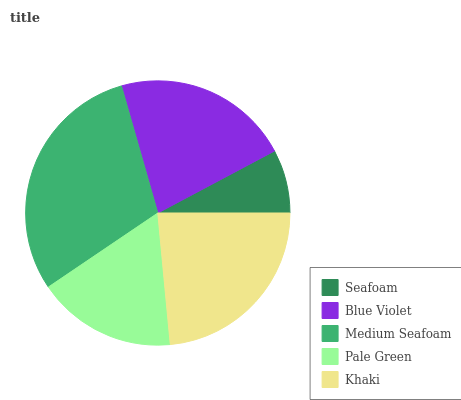Is Seafoam the minimum?
Answer yes or no. Yes. Is Medium Seafoam the maximum?
Answer yes or no. Yes. Is Blue Violet the minimum?
Answer yes or no. No. Is Blue Violet the maximum?
Answer yes or no. No. Is Blue Violet greater than Seafoam?
Answer yes or no. Yes. Is Seafoam less than Blue Violet?
Answer yes or no. Yes. Is Seafoam greater than Blue Violet?
Answer yes or no. No. Is Blue Violet less than Seafoam?
Answer yes or no. No. Is Blue Violet the high median?
Answer yes or no. Yes. Is Blue Violet the low median?
Answer yes or no. Yes. Is Khaki the high median?
Answer yes or no. No. Is Medium Seafoam the low median?
Answer yes or no. No. 